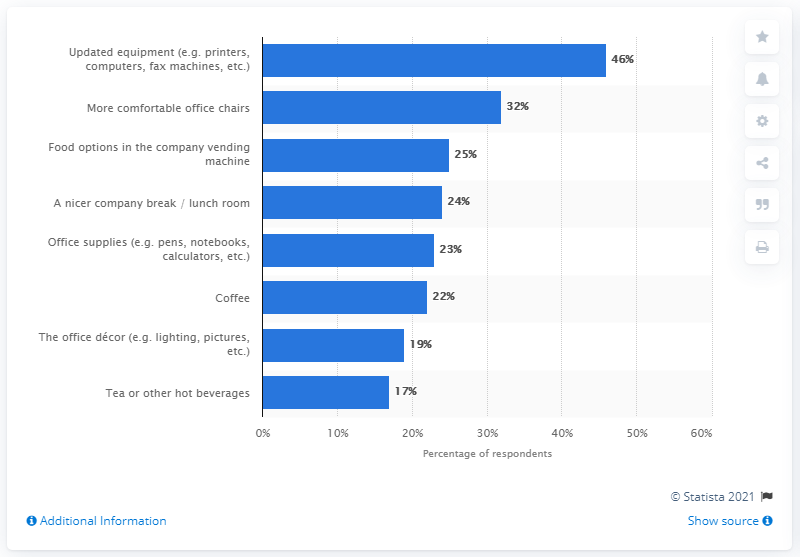Identify some key points in this picture. According to the survey, 25% of respondents expressed a desire for the company to allocate funds towards improving the food options available in their vending machines. 